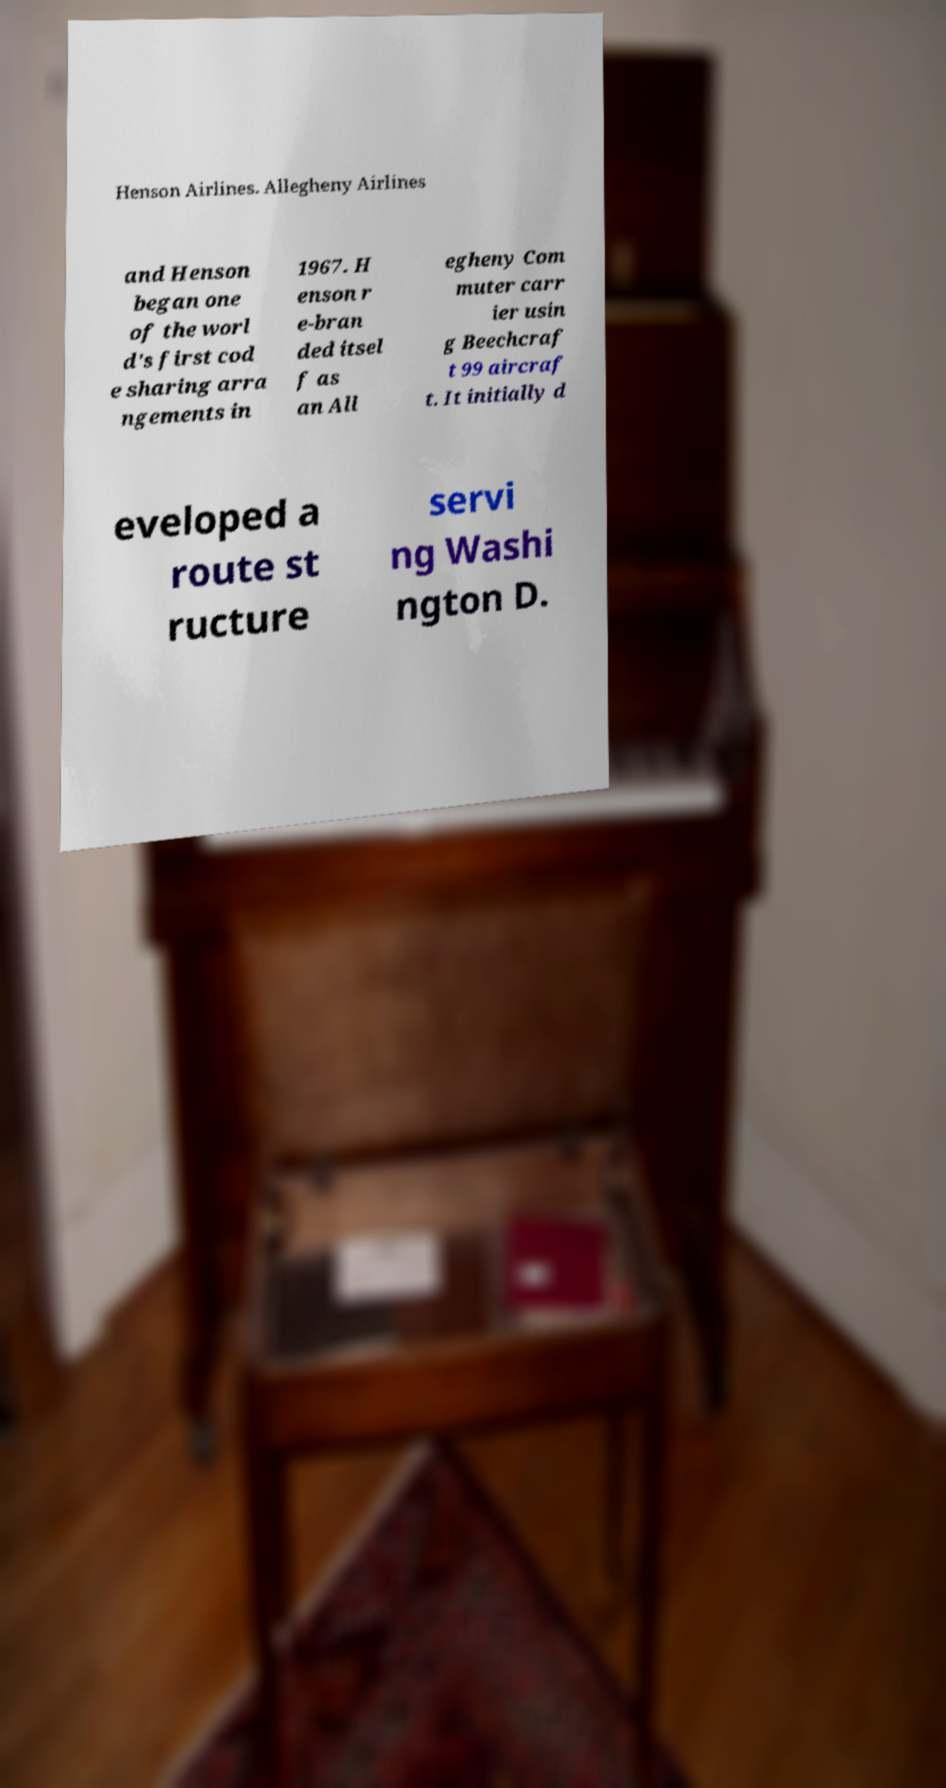Could you assist in decoding the text presented in this image and type it out clearly? Henson Airlines. Allegheny Airlines and Henson began one of the worl d's first cod e sharing arra ngements in 1967. H enson r e-bran ded itsel f as an All egheny Com muter carr ier usin g Beechcraf t 99 aircraf t. It initially d eveloped a route st ructure servi ng Washi ngton D. 